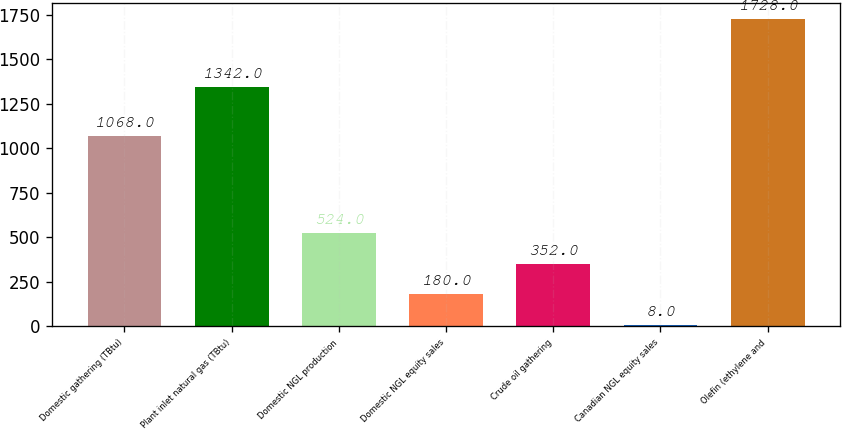Convert chart. <chart><loc_0><loc_0><loc_500><loc_500><bar_chart><fcel>Domestic gathering (TBtu)<fcel>Plant inlet natural gas (TBtu)<fcel>Domestic NGL production<fcel>Domestic NGL equity sales<fcel>Crude oil gathering<fcel>Canadian NGL equity sales<fcel>Olefin (ethylene and<nl><fcel>1068<fcel>1342<fcel>524<fcel>180<fcel>352<fcel>8<fcel>1728<nl></chart> 